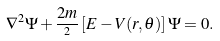<formula> <loc_0><loc_0><loc_500><loc_500>\nabla ^ { 2 } \Psi + \frac { 2 m } { { } ^ { 2 } } \left [ E - V ( r , \theta ) \right ] \Psi = 0 .</formula> 